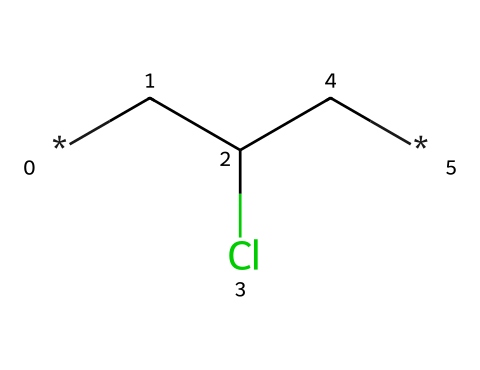What is the main functional group in this chemical? The chemical contains a chlorine atom (Cl) attached to a carbon (C) atom, which defines it as a chloroalkane and indicates the presence of the functional group – halide.
Answer: halide How many carbon atoms are in this chemical structure? By examining the SMILES representation, we see two carbon atoms (C) and one additional carbon atom (CC) in the chain, making it a total of three carbon atoms.
Answer: three What type of polymer is represented by this chemical? The presence of vinyl (C=C) and chlorine (Cl) indicates it's polyvinyl chloride, a common type of synthetic polymer used in various applications, including records.
Answer: polyvinyl chloride How many total atoms are present in this structure? Counting the atoms in the SMILES representation, we see three carbon atoms, one chlorine atom, and one hydrogen atom for a total of five atoms in this structure.
Answer: five What does the chlorine substituent indicate about the properties of this chemical? The chlorine substituent enhances the chemical's polarity, making it behave differently compared to hydrocarbons, affecting properties such as flexibility and durability in vinyl applications.
Answer: polarity Is this chemical classified as saturated or unsaturated? Based on the presence of a double bond (C=C), it is classified as unsaturated, as unsaturated hydrocarbons contain one or more double bonds between carbon atoms.
Answer: unsaturated 